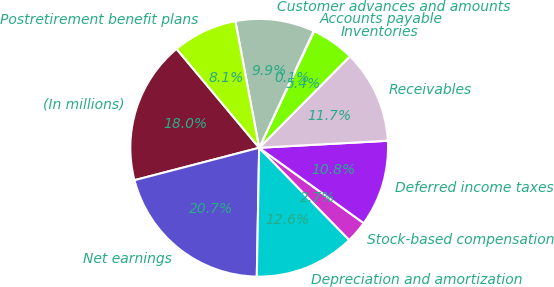Convert chart. <chart><loc_0><loc_0><loc_500><loc_500><pie_chart><fcel>(In millions)<fcel>Net earnings<fcel>Depreciation and amortization<fcel>Stock-based compensation<fcel>Deferred income taxes<fcel>Receivables<fcel>Inventories<fcel>Accounts payable<fcel>Customer advances and amounts<fcel>Postretirement benefit plans<nl><fcel>17.97%<fcel>20.66%<fcel>12.6%<fcel>2.75%<fcel>10.81%<fcel>11.7%<fcel>5.43%<fcel>0.06%<fcel>9.91%<fcel>8.12%<nl></chart> 